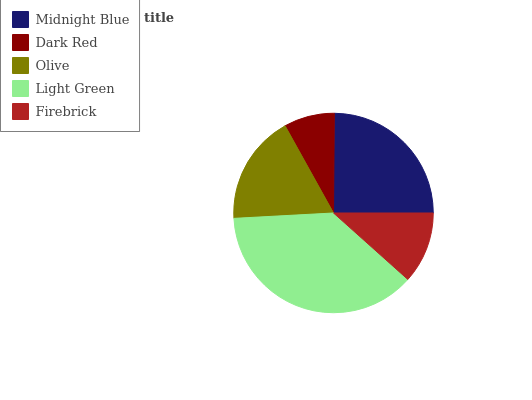Is Dark Red the minimum?
Answer yes or no. Yes. Is Light Green the maximum?
Answer yes or no. Yes. Is Olive the minimum?
Answer yes or no. No. Is Olive the maximum?
Answer yes or no. No. Is Olive greater than Dark Red?
Answer yes or no. Yes. Is Dark Red less than Olive?
Answer yes or no. Yes. Is Dark Red greater than Olive?
Answer yes or no. No. Is Olive less than Dark Red?
Answer yes or no. No. Is Olive the high median?
Answer yes or no. Yes. Is Olive the low median?
Answer yes or no. Yes. Is Midnight Blue the high median?
Answer yes or no. No. Is Light Green the low median?
Answer yes or no. No. 